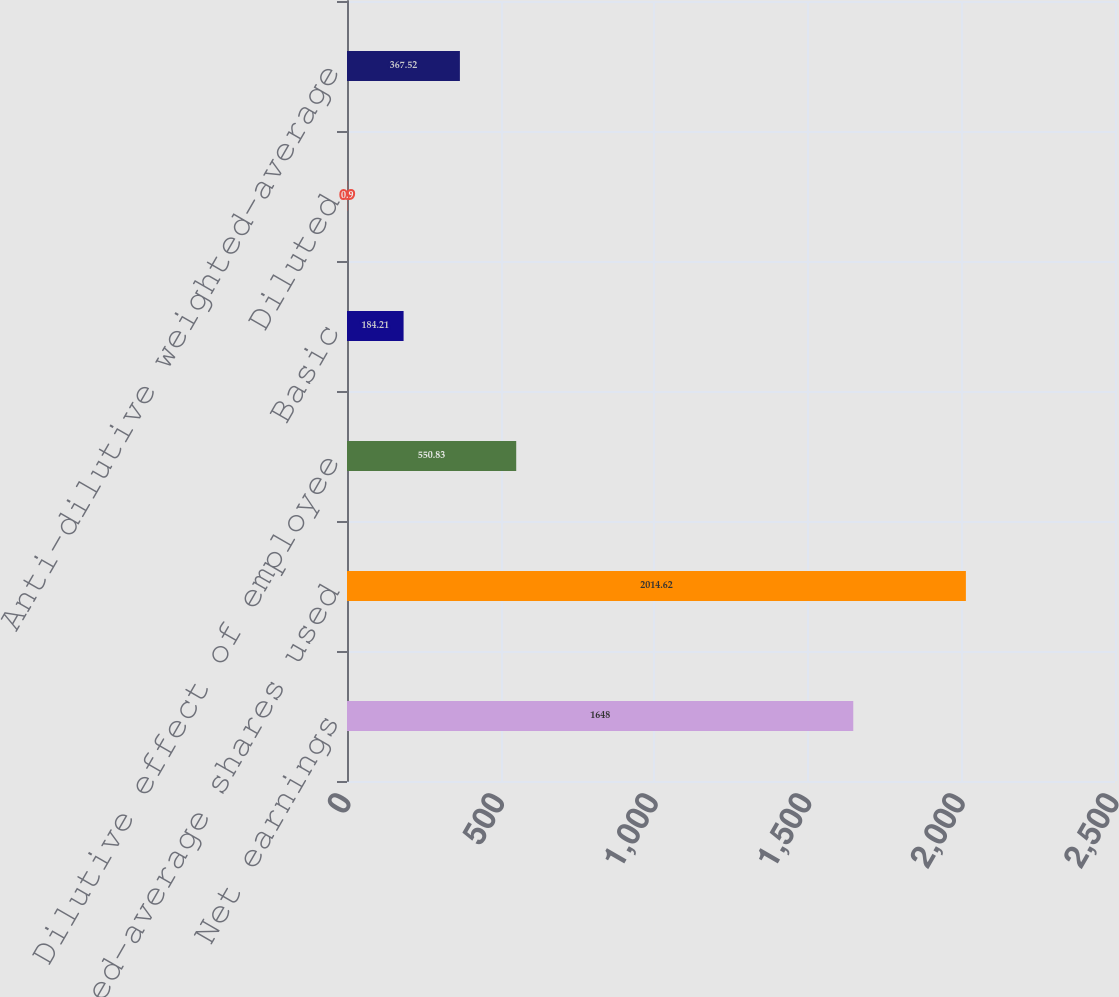<chart> <loc_0><loc_0><loc_500><loc_500><bar_chart><fcel>Net earnings<fcel>Weighted-average shares used<fcel>Dilutive effect of employee<fcel>Basic<fcel>Diluted<fcel>Anti-dilutive weighted-average<nl><fcel>1648<fcel>2014.62<fcel>550.83<fcel>184.21<fcel>0.9<fcel>367.52<nl></chart> 